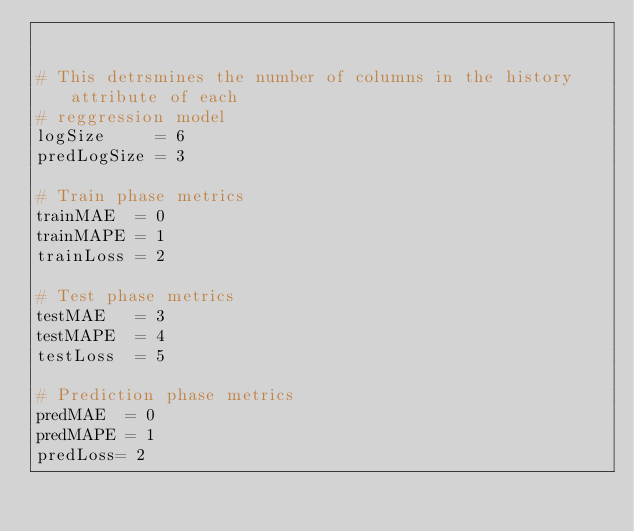<code> <loc_0><loc_0><loc_500><loc_500><_Python_>

# This detrsmines the number of columns in the history attribute of each 
# reggression model
logSize     = 6
predLogSize = 3

# Train phase metrics
trainMAE  = 0
trainMAPE = 1
trainLoss = 2

# Test phase metrics
testMAE   = 3
testMAPE  = 4
testLoss  = 5

# Prediction phase metrics
predMAE  = 0
predMAPE = 1
predLoss= 2
</code> 